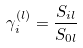Convert formula to latex. <formula><loc_0><loc_0><loc_500><loc_500>\gamma _ { i } ^ { ( l ) } = \frac { S _ { i l } } { S _ { 0 l } }</formula> 